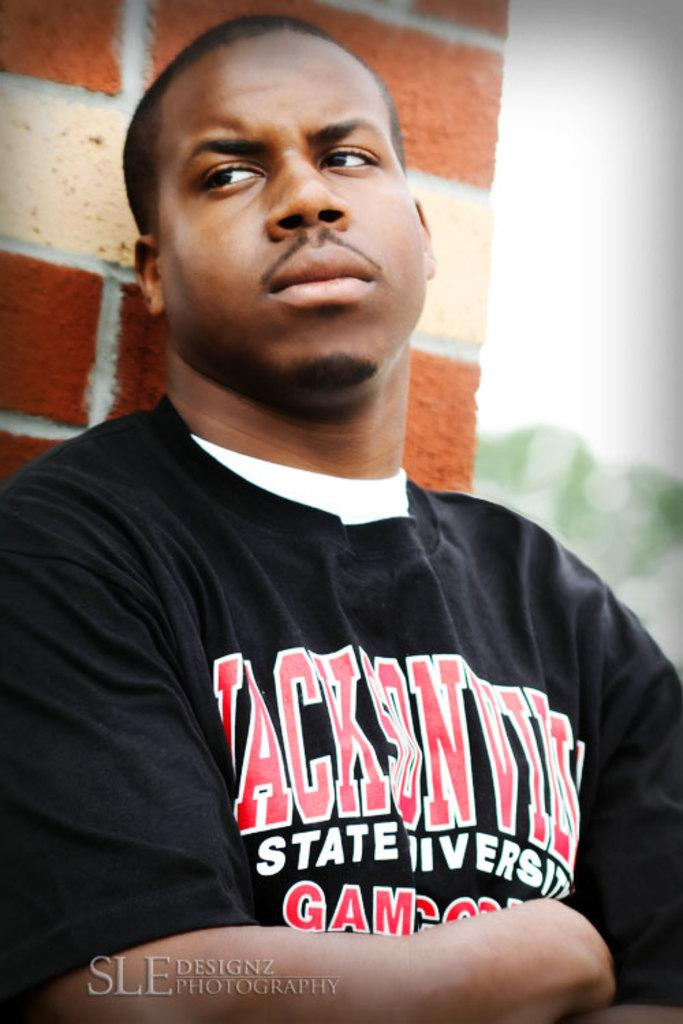<image>
Present a compact description of the photo's key features. A man wearing a shirt that says Jackson State university stands against a brick wall 